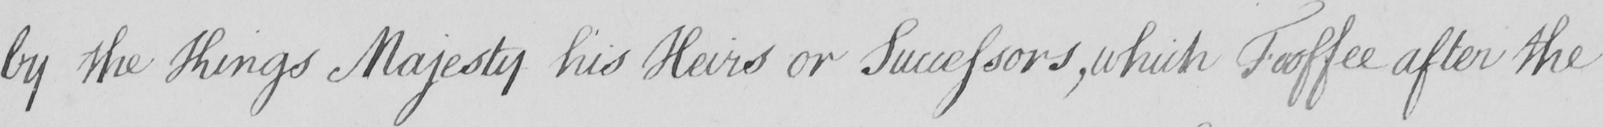Can you read and transcribe this handwriting? by the King ' s Majesty his Heirs or Successors , which Feoffee after the 